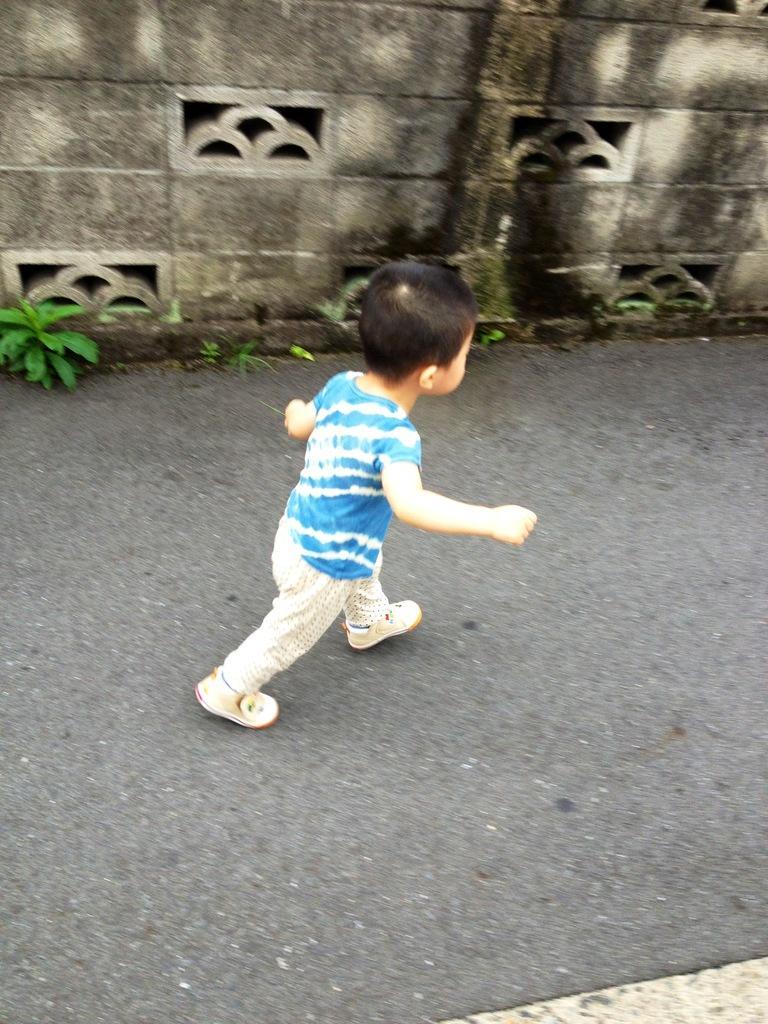Who is the main subject in the image? There is a small boy in the image. What is the boy doing in the image? The boy is walking. What color is the shirt the boy is wearing? The boy is wearing a blue color shirt. What can be seen in the background of the image? There is a plant and a wall in the background of the image. Can you see any cherries hanging from the plant in the background? There is no mention of cherries in the image, and the plant in the background is not described in detail. 